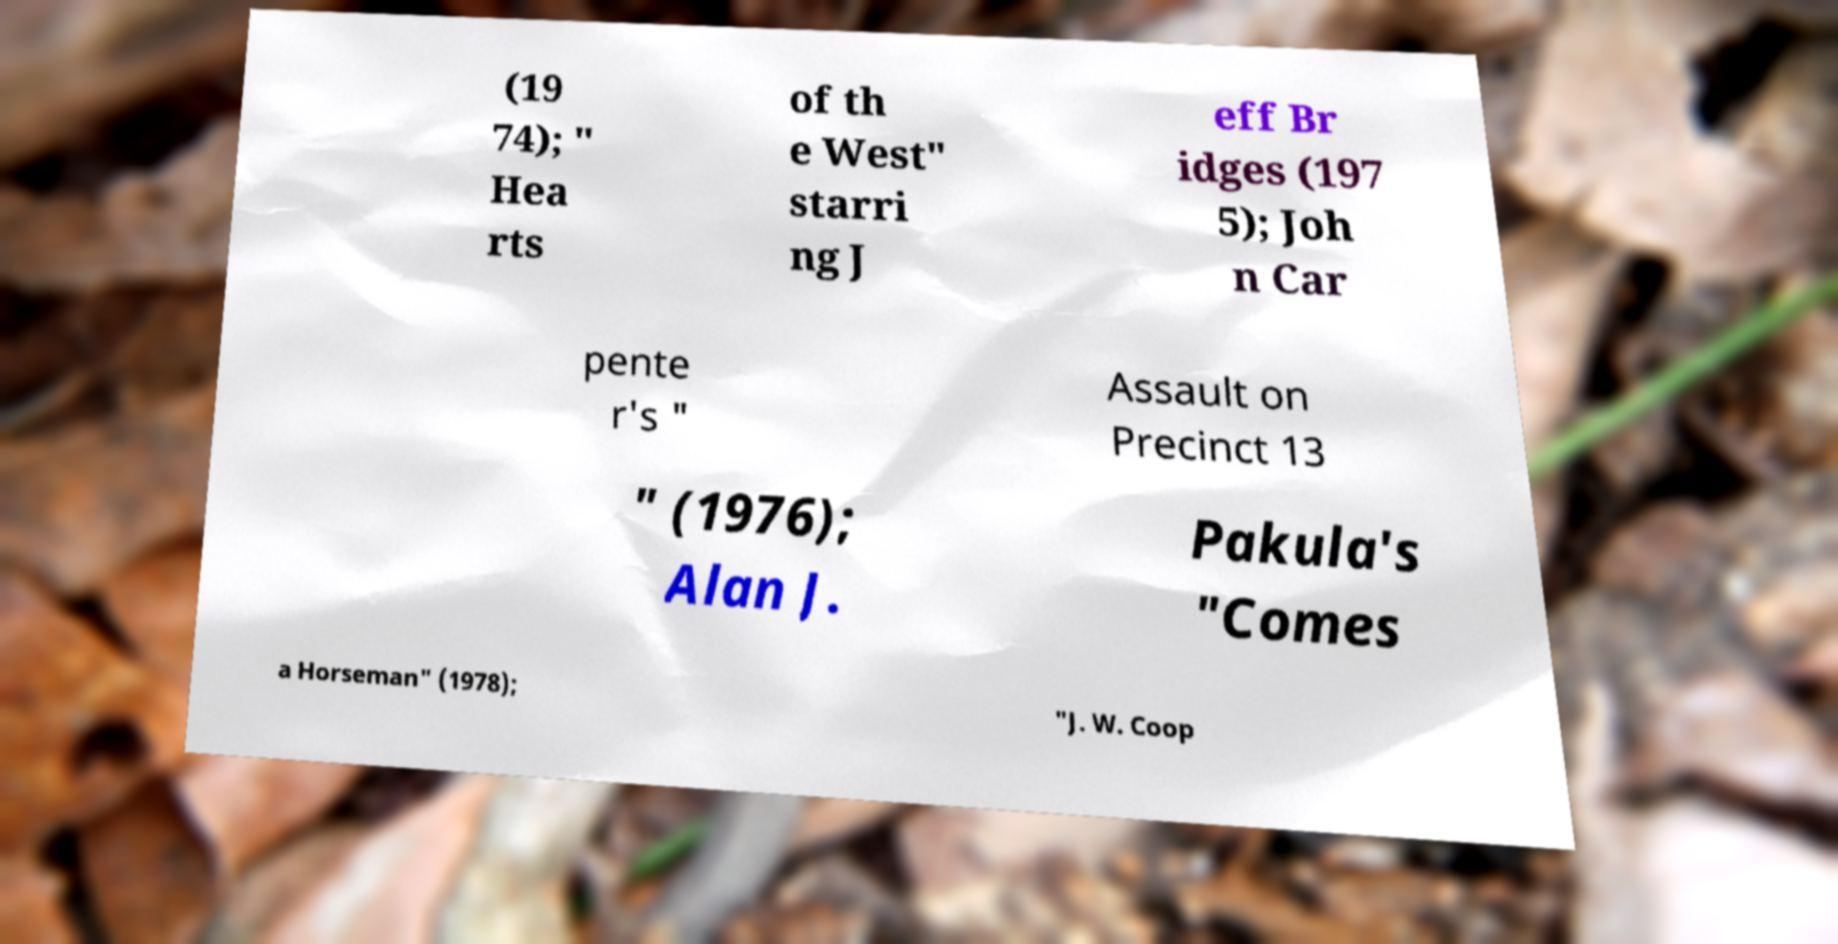Please read and relay the text visible in this image. What does it say? (19 74); " Hea rts of th e West" starri ng J eff Br idges (197 5); Joh n Car pente r's " Assault on Precinct 13 " (1976); Alan J. Pakula's "Comes a Horseman" (1978); "J. W. Coop 